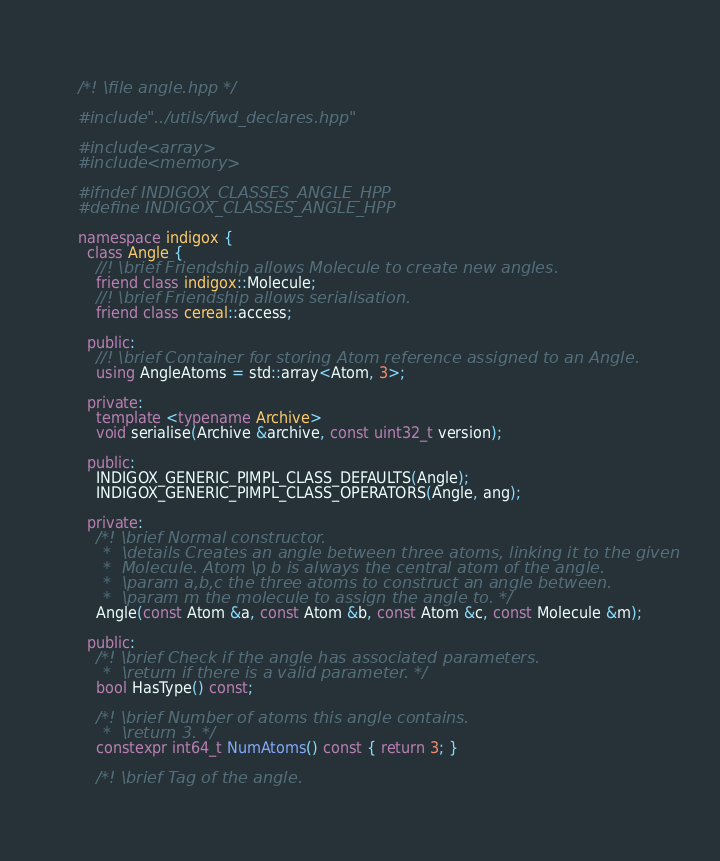Convert code to text. <code><loc_0><loc_0><loc_500><loc_500><_C++_>/*! \file angle.hpp */

#include "../utils/fwd_declares.hpp"

#include <array>
#include <memory>

#ifndef INDIGOX_CLASSES_ANGLE_HPP
#define INDIGOX_CLASSES_ANGLE_HPP

namespace indigox {
  class Angle {
    //! \brief Friendship allows Molecule to create new angles.
    friend class indigox::Molecule;
    //! \brief Friendship allows serialisation.
    friend class cereal::access;

  public:
    //! \brief Container for storing Atom reference assigned to an Angle.
    using AngleAtoms = std::array<Atom, 3>;

  private:
    template <typename Archive>
    void serialise(Archive &archive, const uint32_t version);

  public:
    INDIGOX_GENERIC_PIMPL_CLASS_DEFAULTS(Angle);
    INDIGOX_GENERIC_PIMPL_CLASS_OPERATORS(Angle, ang);

  private:
    /*! \brief Normal constructor.
     *  \details Creates an angle between three atoms, linking it to the given
     *  Molecule. Atom \p b is always the central atom of the angle.
     *  \param a,b,c the three atoms to construct an angle between.
     *  \param m the molecule to assign the angle to. */
    Angle(const Atom &a, const Atom &b, const Atom &c, const Molecule &m);

  public:
    /*! \brief Check if the angle has associated parameters.
     *  \return if there is a valid parameter. */
    bool HasType() const;

    /*! \brief Number of atoms this angle contains.
     *  \return 3. */
    constexpr int64_t NumAtoms() const { return 3; }

    /*! \brief Tag of the angle.</code> 